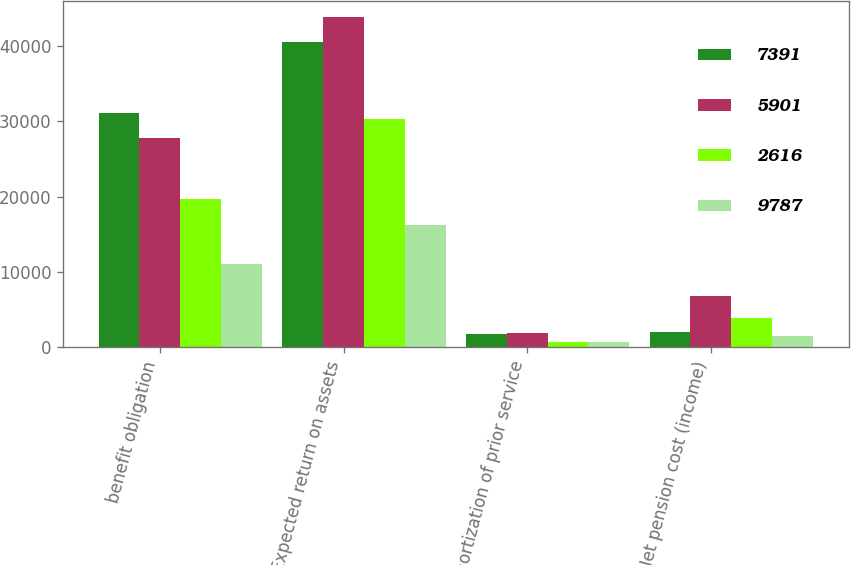Convert chart. <chart><loc_0><loc_0><loc_500><loc_500><stacked_bar_chart><ecel><fcel>benefit obligation<fcel>Expected return on assets<fcel>Amortization of prior service<fcel>Net pension cost (income)<nl><fcel>7391<fcel>31058<fcel>40514<fcel>1743<fcel>2074<nl><fcel>5901<fcel>27737<fcel>43827<fcel>1923<fcel>6776<nl><fcel>2616<fcel>19747<fcel>30300<fcel>744<fcel>3908<nl><fcel>9787<fcel>11013<fcel>16197<fcel>705<fcel>1508<nl></chart> 